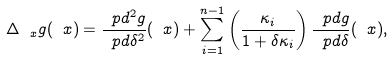<formula> <loc_0><loc_0><loc_500><loc_500>\Delta _ { \ x } g ( \ x ) = \frac { \ p d ^ { 2 } g } { \ p d \delta ^ { 2 } } ( \ x ) + \sum _ { i = 1 } ^ { n - 1 } \left ( \frac { \kappa _ { i } } { 1 + \delta \kappa _ { i } } \right ) \frac { \ p d g } { \ p d \delta } ( \ x ) ,</formula> 